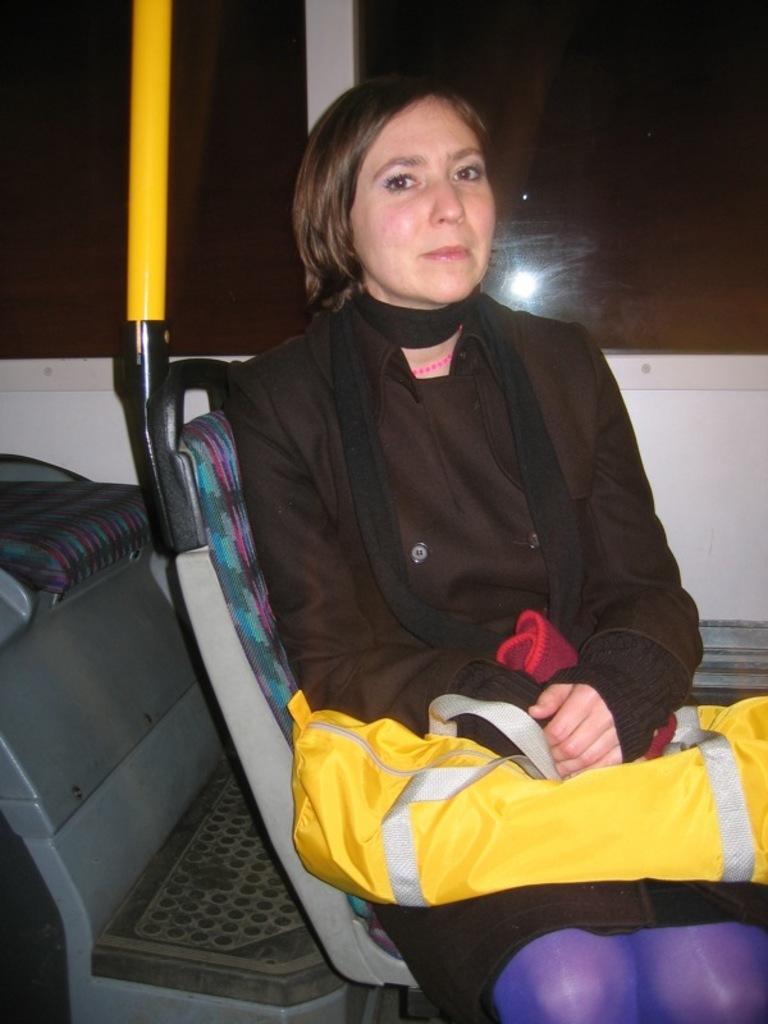Please provide a concise description of this image. In this image there is a women sitting in a bus, keeping a bag in her lap, in the background there are glass windows. 